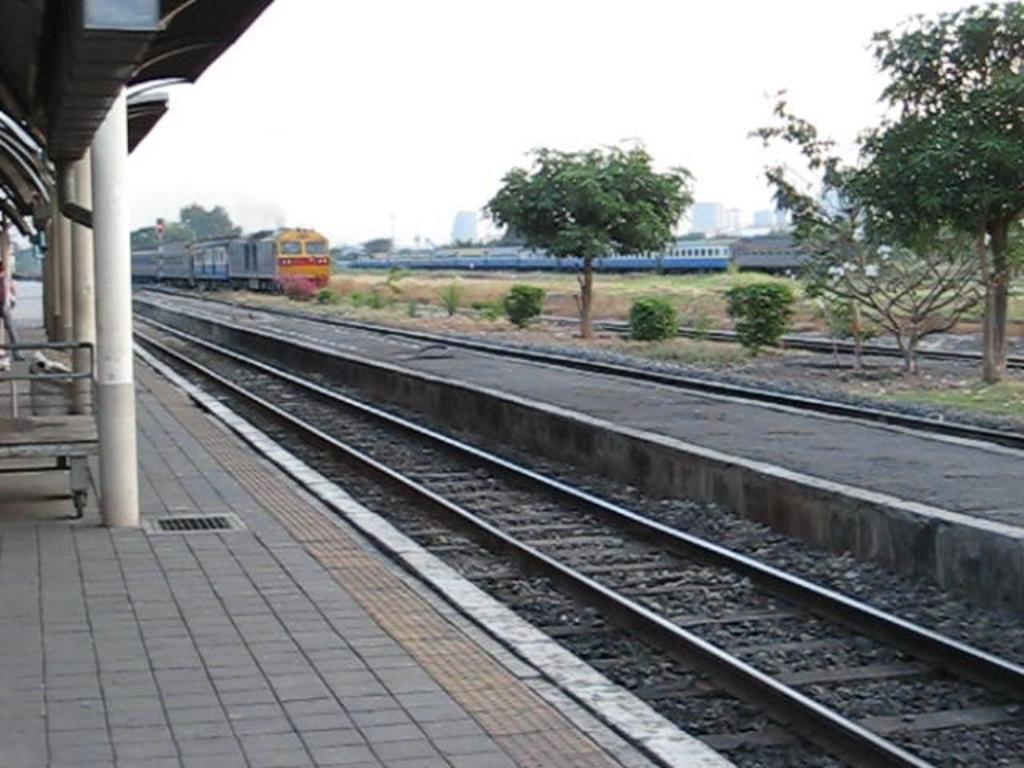What is the main subject of the image? The main subject of the image is a train. What can be seen beneath the train? Railway tracks are visible in the image. What type of vegetation is present in the image? There are trees, shrubs, and bushes visible in the image. What is visible in the sky? The sky is visible in the image. What type of structures can be seen in the image? There are buildings and a shed present in the image. What other objects are visible in the image? Poles and a trolley are visible in the image. How many quarters are visible on the train in the image? There are no quarters visible on the train in the image. What type of hydrant can be seen near the train in the image? There is no hydrant present in the image. 